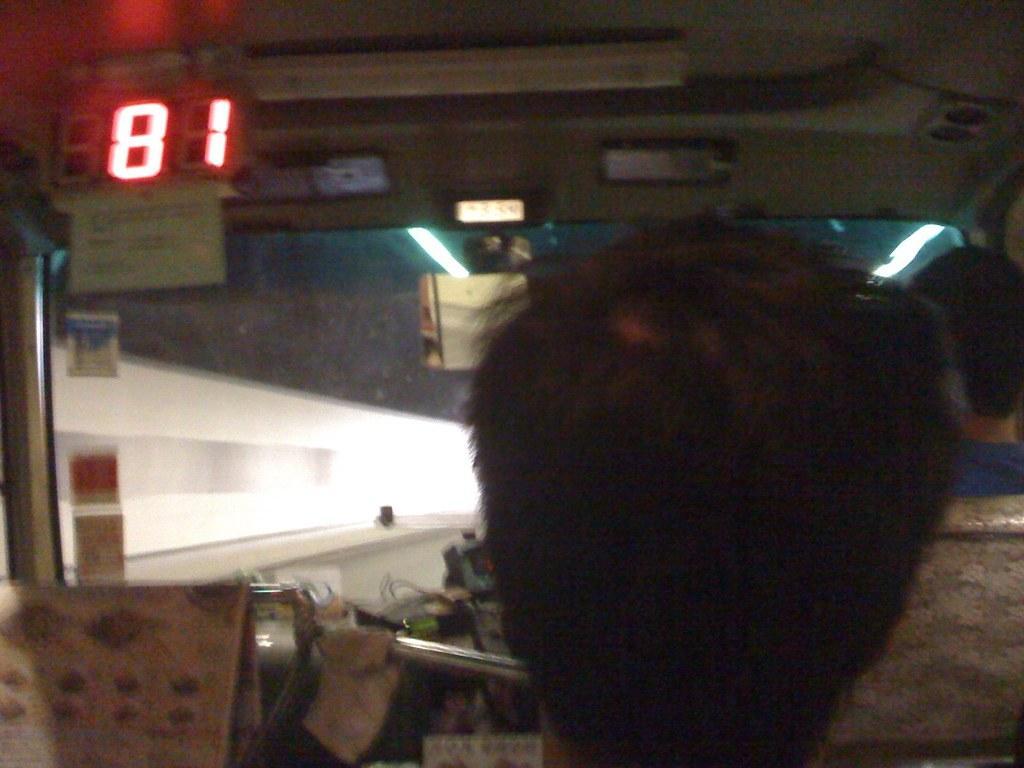How would you summarize this image in a sentence or two? In the image there is a person sitting inside a vehicle with a light board on the left side. 